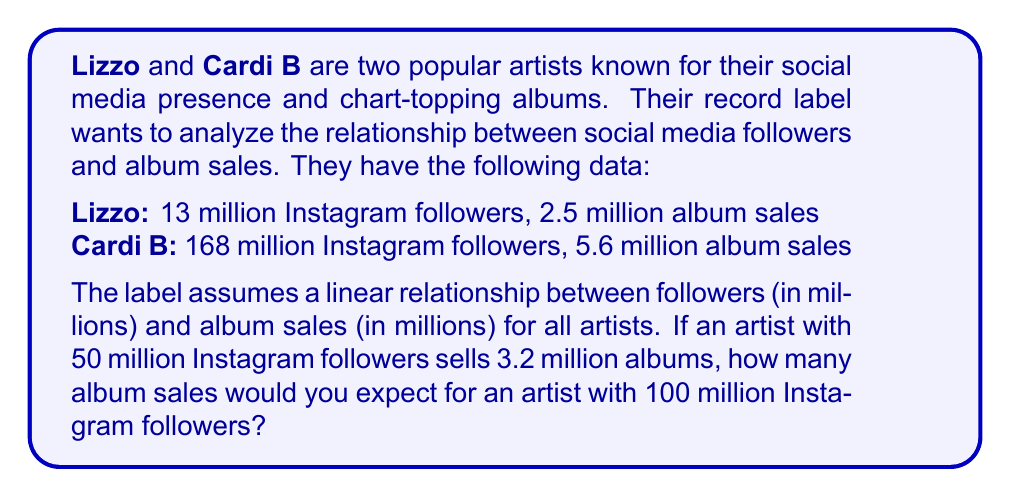Give your solution to this math problem. Let's approach this step-by-step:

1) We need to find the linear equation in the form $y = mx + b$, where:
   $y$ = album sales (in millions)
   $x$ = Instagram followers (in millions)
   $m$ = slope
   $b$ = y-intercept

2) We can use the two given data points to find the slope:
   $m = \frac{y_2 - y_1}{x_2 - x_1} = \frac{5.6 - 2.5}{168 - 13} = \frac{3.1}{155} = 0.02$

3) Now we can use either point to find $b$. Let's use Lizzo's data:
   $2.5 = 0.02(13) + b$
   $2.5 = 0.26 + b$
   $b = 2.24$

4) Our equation is: $y = 0.02x + 2.24$

5) We can verify this with the given third point (50 million followers, 3.2 million sales):
   $3.2 ≈ 0.02(50) + 2.24 = 3.24$ (close enough, considering rounding)

6) Now, for 100 million followers:
   $y = 0.02(100) + 2.24 = 2 + 2.24 = 4.24$

Therefore, we would expect 4.24 million album sales for an artist with 100 million Instagram followers.
Answer: 4.24 million album sales 